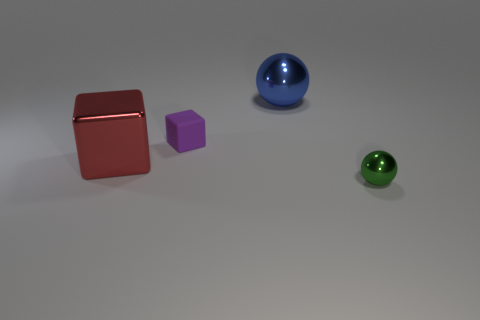What color is the metal sphere that is behind the tiny green shiny sphere?
Provide a short and direct response. Blue. What shape is the blue thing?
Your answer should be very brief. Sphere. Is there a tiny purple matte block that is behind the red thing in front of the metallic object behind the tiny cube?
Your response must be concise. Yes. There is a metal object in front of the big thing that is in front of the tiny thing that is left of the big blue metallic sphere; what color is it?
Give a very brief answer. Green. There is a green thing that is the same shape as the large blue thing; what is it made of?
Your answer should be compact. Metal. There is a metal object that is on the left side of the sphere left of the green sphere; what size is it?
Ensure brevity in your answer.  Large. There is a tiny object to the left of the small metallic thing; what is it made of?
Offer a very short reply. Rubber. There is a blue ball that is made of the same material as the red block; what size is it?
Give a very brief answer. Large. How many other objects are the same shape as the small purple matte object?
Your answer should be compact. 1. There is a large red thing; is its shape the same as the tiny thing left of the blue metallic thing?
Offer a very short reply. Yes. 